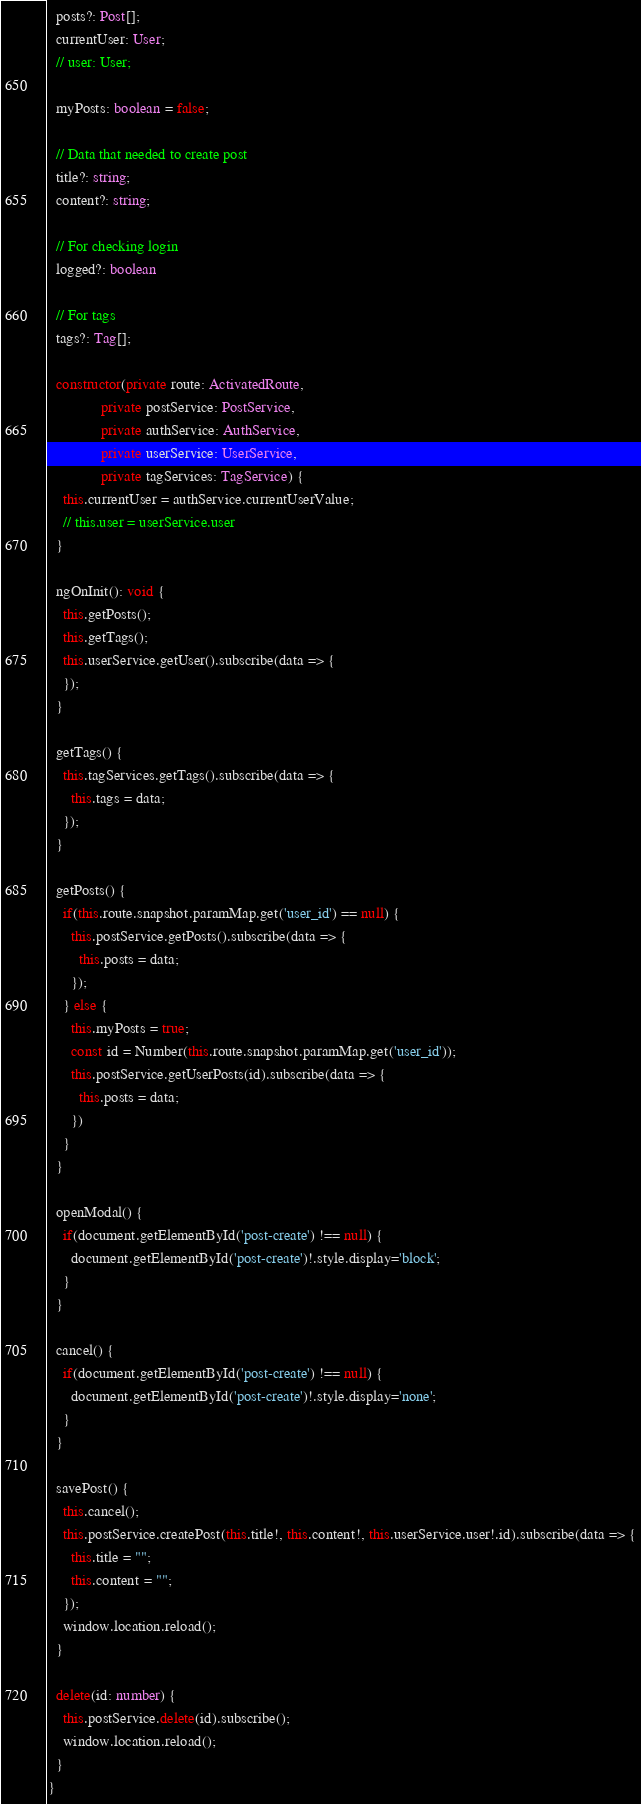<code> <loc_0><loc_0><loc_500><loc_500><_TypeScript_>  posts?: Post[];
  currentUser: User;
  // user: User;

  myPosts: boolean = false;

  // Data that needed to create post
  title?: string;
  content?: string;

  // For checking login
  logged?: boolean

  // For tags
  tags?: Tag[];

  constructor(private route: ActivatedRoute,
              private postService: PostService,
              private authService: AuthService,
              private userService: UserService,
              private tagServices: TagService) {
    this.currentUser = authService.currentUserValue;
    // this.user = userService.user
  }

  ngOnInit(): void {
    this.getPosts();
    this.getTags();
    this.userService.getUser().subscribe(data => {
    });
  }

  getTags() {
    this.tagServices.getTags().subscribe(data => {
      this.tags = data;
    });
  }

  getPosts() {
    if(this.route.snapshot.paramMap.get('user_id') == null) {
      this.postService.getPosts().subscribe(data => {
        this.posts = data;
      });
    } else {
      this.myPosts = true;
      const id = Number(this.route.snapshot.paramMap.get('user_id'));
      this.postService.getUserPosts(id).subscribe(data => {
        this.posts = data;
      })
    }
  }

  openModal() {
    if(document.getElementById('post-create') !== null) {
      document.getElementById('post-create')!.style.display='block';
    }
  }

  cancel() {
    if(document.getElementById('post-create') !== null) {
      document.getElementById('post-create')!.style.display='none';
    }
  }

  savePost() {
    this.cancel();
    this.postService.createPost(this.title!, this.content!, this.userService.user!.id).subscribe(data => {
      this.title = "";
      this.content = "";
    });
    window.location.reload();
  }

  delete(id: number) {
    this.postService.delete(id).subscribe();
    window.location.reload();
  }
}
</code> 